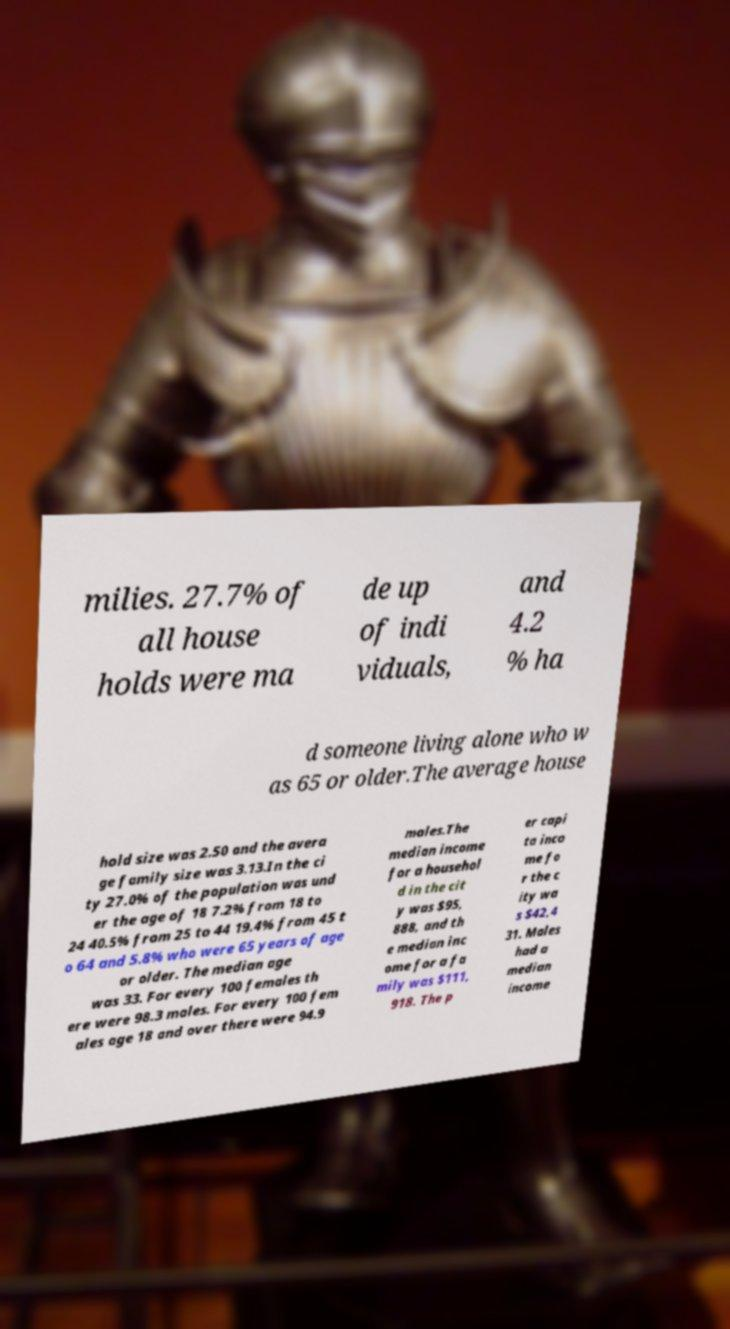Please identify and transcribe the text found in this image. milies. 27.7% of all house holds were ma de up of indi viduals, and 4.2 % ha d someone living alone who w as 65 or older.The average house hold size was 2.50 and the avera ge family size was 3.13.In the ci ty 27.0% of the population was und er the age of 18 7.2% from 18 to 24 40.5% from 25 to 44 19.4% from 45 t o 64 and 5.8% who were 65 years of age or older. The median age was 33. For every 100 females th ere were 98.3 males. For every 100 fem ales age 18 and over there were 94.9 males.The median income for a househol d in the cit y was $95, 888, and th e median inc ome for a fa mily was $111, 918. The p er capi ta inco me fo r the c ity wa s $42,4 31. Males had a median income 